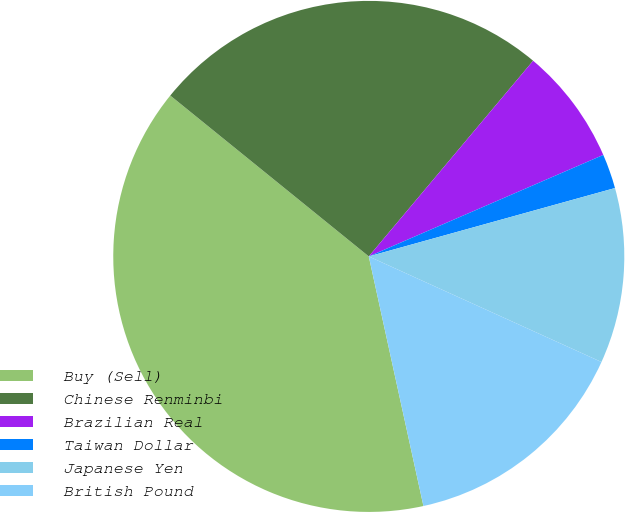Convert chart to OTSL. <chart><loc_0><loc_0><loc_500><loc_500><pie_chart><fcel>Buy (Sell)<fcel>Chinese Renminbi<fcel>Brazilian Real<fcel>Taiwan Dollar<fcel>Japanese Yen<fcel>British Pound<nl><fcel>39.27%<fcel>25.28%<fcel>7.38%<fcel>2.19%<fcel>11.09%<fcel>14.79%<nl></chart> 